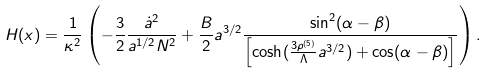Convert formula to latex. <formula><loc_0><loc_0><loc_500><loc_500>H ( x ) = \frac { 1 } { \kappa ^ { 2 } } \left ( - \frac { 3 } { 2 } \frac { { \dot { a } } ^ { 2 } } { a ^ { 1 / 2 } N ^ { 2 } } + \frac { B } { 2 } a ^ { 3 / 2 } \frac { \sin ^ { 2 } ( \alpha - \beta ) } { \left [ \cosh ( \frac { 3 \rho ^ { ( 5 ) } } { \Lambda } a ^ { 3 / 2 } ) + \cos ( \alpha - \beta ) \right ] } \right ) .</formula> 